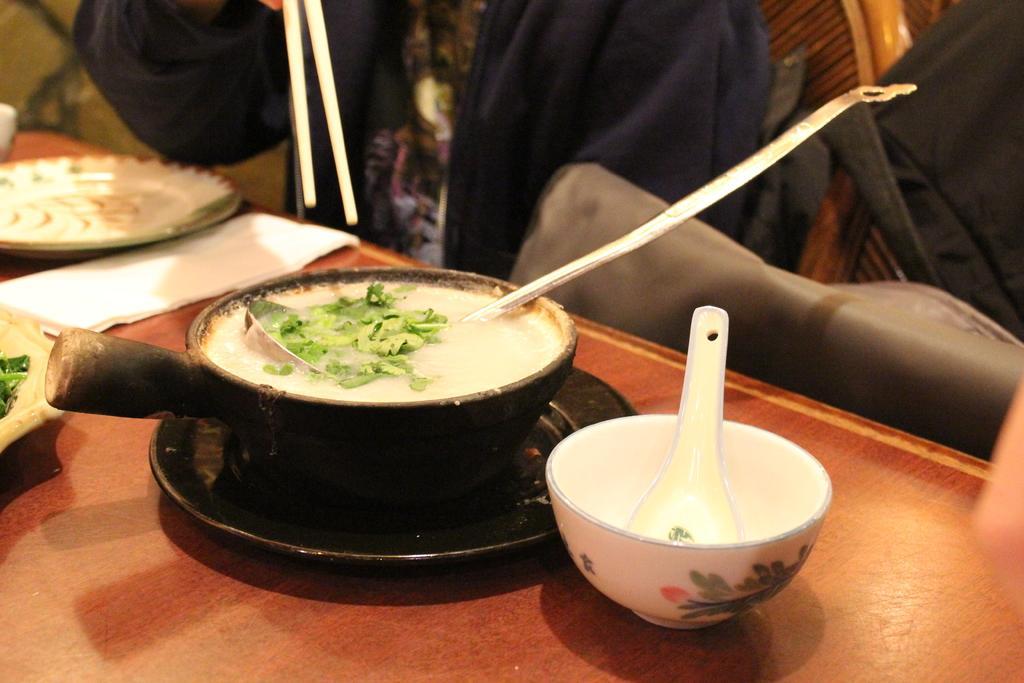Could you give a brief overview of what you see in this image? This is the picture taken in restaurant, this is a table on the table there is a bowl, spoon, plate and a tissue. Behind the table there are people sitting on a chair and holding chopsticks. 